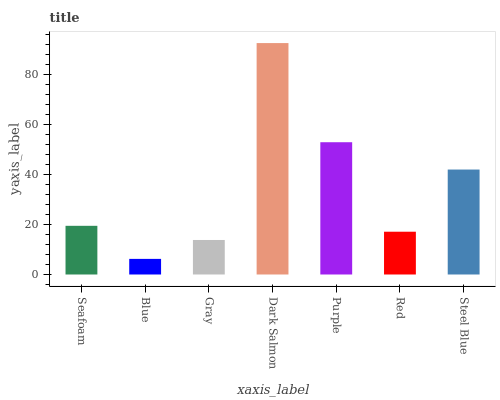Is Blue the minimum?
Answer yes or no. Yes. Is Dark Salmon the maximum?
Answer yes or no. Yes. Is Gray the minimum?
Answer yes or no. No. Is Gray the maximum?
Answer yes or no. No. Is Gray greater than Blue?
Answer yes or no. Yes. Is Blue less than Gray?
Answer yes or no. Yes. Is Blue greater than Gray?
Answer yes or no. No. Is Gray less than Blue?
Answer yes or no. No. Is Seafoam the high median?
Answer yes or no. Yes. Is Seafoam the low median?
Answer yes or no. Yes. Is Purple the high median?
Answer yes or no. No. Is Red the low median?
Answer yes or no. No. 